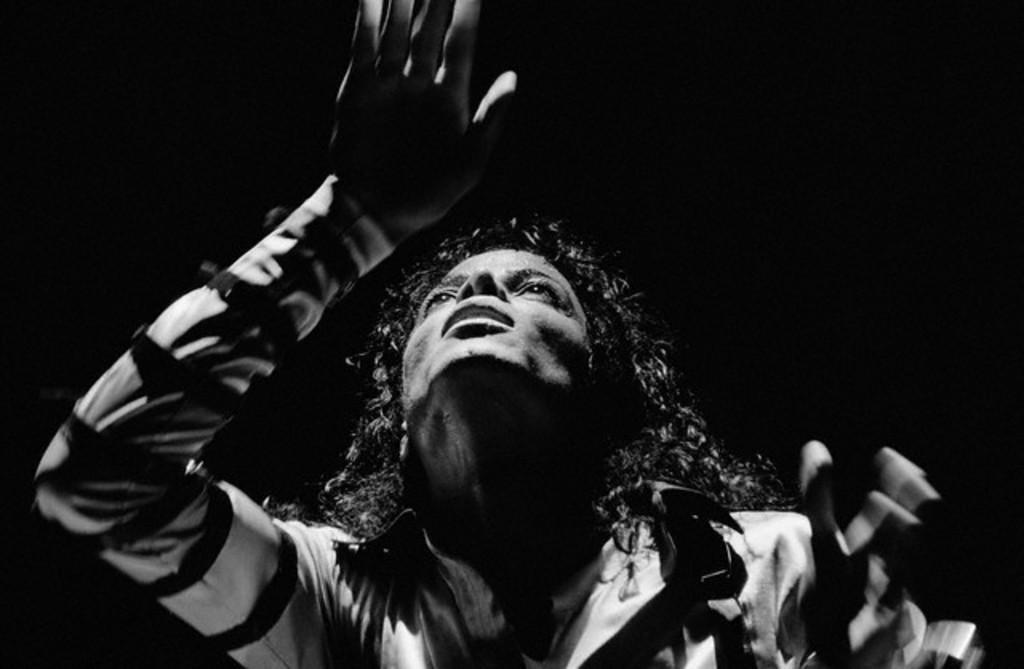Please provide a concise description of this image. This is a black and white image and here we can see a man. 